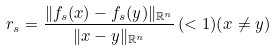Convert formula to latex. <formula><loc_0><loc_0><loc_500><loc_500>r _ { s } = \frac { \| f _ { s } ( x ) - f _ { s } ( y ) \| _ { \mathbb { R } ^ { n } } } { \| x - y \| _ { \mathbb { R } ^ { n } } } \, ( < 1 ) ( x \neq y )</formula> 